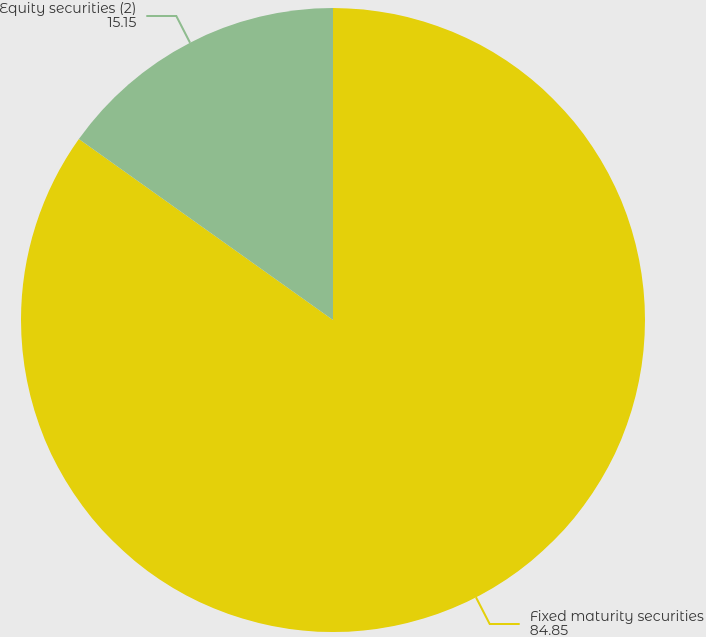Convert chart. <chart><loc_0><loc_0><loc_500><loc_500><pie_chart><fcel>Fixed maturity securities<fcel>Equity securities (2)<nl><fcel>84.85%<fcel>15.15%<nl></chart> 